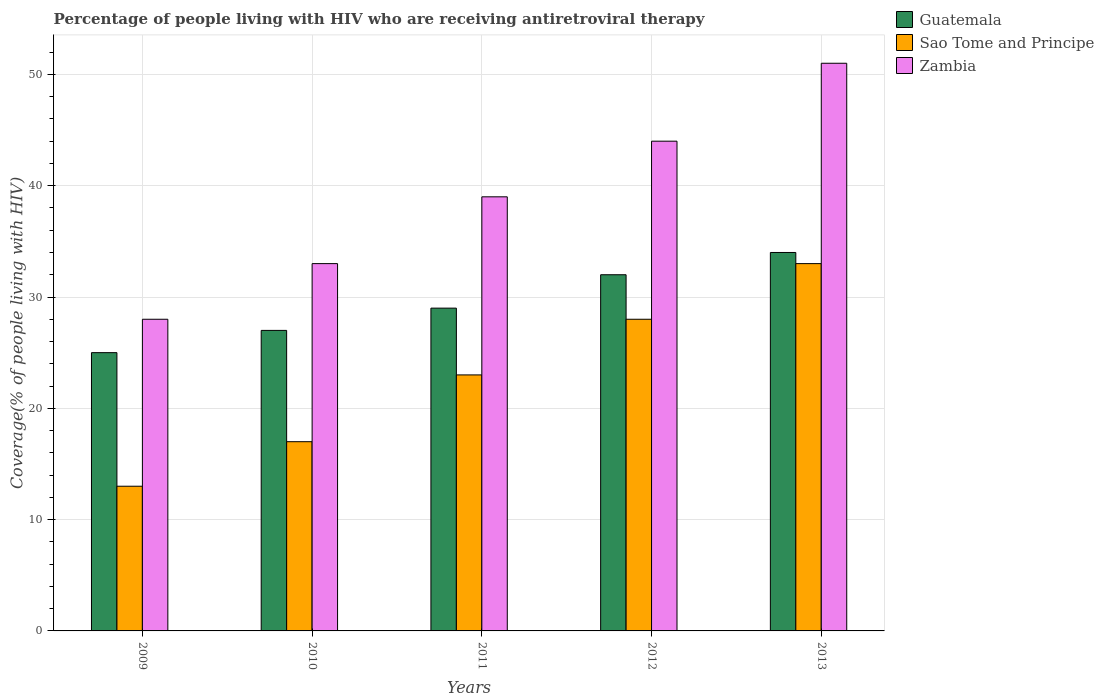Are the number of bars per tick equal to the number of legend labels?
Offer a very short reply. Yes. In how many cases, is the number of bars for a given year not equal to the number of legend labels?
Your answer should be compact. 0. What is the percentage of the HIV infected people who are receiving antiretroviral therapy in Zambia in 2010?
Provide a succinct answer. 33. Across all years, what is the maximum percentage of the HIV infected people who are receiving antiretroviral therapy in Zambia?
Your answer should be very brief. 51. Across all years, what is the minimum percentage of the HIV infected people who are receiving antiretroviral therapy in Zambia?
Give a very brief answer. 28. In which year was the percentage of the HIV infected people who are receiving antiretroviral therapy in Guatemala maximum?
Offer a very short reply. 2013. In which year was the percentage of the HIV infected people who are receiving antiretroviral therapy in Sao Tome and Principe minimum?
Offer a very short reply. 2009. What is the total percentage of the HIV infected people who are receiving antiretroviral therapy in Zambia in the graph?
Offer a very short reply. 195. What is the difference between the percentage of the HIV infected people who are receiving antiretroviral therapy in Zambia in 2009 and that in 2012?
Your answer should be compact. -16. What is the difference between the percentage of the HIV infected people who are receiving antiretroviral therapy in Guatemala in 2011 and the percentage of the HIV infected people who are receiving antiretroviral therapy in Zambia in 2012?
Offer a terse response. -15. What is the average percentage of the HIV infected people who are receiving antiretroviral therapy in Sao Tome and Principe per year?
Offer a very short reply. 22.8. In the year 2013, what is the difference between the percentage of the HIV infected people who are receiving antiretroviral therapy in Sao Tome and Principe and percentage of the HIV infected people who are receiving antiretroviral therapy in Guatemala?
Keep it short and to the point. -1. In how many years, is the percentage of the HIV infected people who are receiving antiretroviral therapy in Sao Tome and Principe greater than 34 %?
Keep it short and to the point. 0. What is the ratio of the percentage of the HIV infected people who are receiving antiretroviral therapy in Guatemala in 2010 to that in 2011?
Your answer should be very brief. 0.93. Is the percentage of the HIV infected people who are receiving antiretroviral therapy in Zambia in 2012 less than that in 2013?
Your response must be concise. Yes. What is the difference between the highest and the second highest percentage of the HIV infected people who are receiving antiretroviral therapy in Sao Tome and Principe?
Your response must be concise. 5. What is the difference between the highest and the lowest percentage of the HIV infected people who are receiving antiretroviral therapy in Sao Tome and Principe?
Ensure brevity in your answer.  20. In how many years, is the percentage of the HIV infected people who are receiving antiretroviral therapy in Guatemala greater than the average percentage of the HIV infected people who are receiving antiretroviral therapy in Guatemala taken over all years?
Offer a very short reply. 2. What does the 3rd bar from the left in 2012 represents?
Make the answer very short. Zambia. What does the 2nd bar from the right in 2011 represents?
Offer a terse response. Sao Tome and Principe. Are all the bars in the graph horizontal?
Provide a short and direct response. No. How many years are there in the graph?
Provide a succinct answer. 5. Does the graph contain any zero values?
Provide a short and direct response. No. How are the legend labels stacked?
Your response must be concise. Vertical. What is the title of the graph?
Give a very brief answer. Percentage of people living with HIV who are receiving antiretroviral therapy. Does "Central Europe" appear as one of the legend labels in the graph?
Your response must be concise. No. What is the label or title of the X-axis?
Provide a succinct answer. Years. What is the label or title of the Y-axis?
Offer a terse response. Coverage(% of people living with HIV). What is the Coverage(% of people living with HIV) of Guatemala in 2009?
Offer a terse response. 25. What is the Coverage(% of people living with HIV) in Guatemala in 2010?
Provide a short and direct response. 27. What is the Coverage(% of people living with HIV) of Sao Tome and Principe in 2010?
Your response must be concise. 17. What is the Coverage(% of people living with HIV) in Zambia in 2010?
Your answer should be compact. 33. What is the Coverage(% of people living with HIV) of Sao Tome and Principe in 2011?
Ensure brevity in your answer.  23. What is the Coverage(% of people living with HIV) in Zambia in 2011?
Your answer should be compact. 39. What is the Coverage(% of people living with HIV) of Guatemala in 2012?
Your answer should be very brief. 32. Across all years, what is the minimum Coverage(% of people living with HIV) of Zambia?
Provide a succinct answer. 28. What is the total Coverage(% of people living with HIV) of Guatemala in the graph?
Offer a very short reply. 147. What is the total Coverage(% of people living with HIV) in Sao Tome and Principe in the graph?
Provide a short and direct response. 114. What is the total Coverage(% of people living with HIV) of Zambia in the graph?
Make the answer very short. 195. What is the difference between the Coverage(% of people living with HIV) of Guatemala in 2009 and that in 2010?
Offer a terse response. -2. What is the difference between the Coverage(% of people living with HIV) of Sao Tome and Principe in 2009 and that in 2010?
Offer a terse response. -4. What is the difference between the Coverage(% of people living with HIV) in Zambia in 2009 and that in 2011?
Give a very brief answer. -11. What is the difference between the Coverage(% of people living with HIV) in Guatemala in 2009 and that in 2012?
Offer a terse response. -7. What is the difference between the Coverage(% of people living with HIV) of Guatemala in 2009 and that in 2013?
Provide a short and direct response. -9. What is the difference between the Coverage(% of people living with HIV) of Sao Tome and Principe in 2010 and that in 2011?
Make the answer very short. -6. What is the difference between the Coverage(% of people living with HIV) in Zambia in 2010 and that in 2011?
Give a very brief answer. -6. What is the difference between the Coverage(% of people living with HIV) of Guatemala in 2010 and that in 2012?
Your response must be concise. -5. What is the difference between the Coverage(% of people living with HIV) of Sao Tome and Principe in 2010 and that in 2012?
Keep it short and to the point. -11. What is the difference between the Coverage(% of people living with HIV) of Zambia in 2010 and that in 2012?
Make the answer very short. -11. What is the difference between the Coverage(% of people living with HIV) of Sao Tome and Principe in 2010 and that in 2013?
Keep it short and to the point. -16. What is the difference between the Coverage(% of people living with HIV) in Zambia in 2010 and that in 2013?
Keep it short and to the point. -18. What is the difference between the Coverage(% of people living with HIV) of Sao Tome and Principe in 2011 and that in 2012?
Ensure brevity in your answer.  -5. What is the difference between the Coverage(% of people living with HIV) in Zambia in 2011 and that in 2012?
Your answer should be compact. -5. What is the difference between the Coverage(% of people living with HIV) in Zambia in 2011 and that in 2013?
Keep it short and to the point. -12. What is the difference between the Coverage(% of people living with HIV) of Sao Tome and Principe in 2012 and that in 2013?
Offer a very short reply. -5. What is the difference between the Coverage(% of people living with HIV) in Zambia in 2012 and that in 2013?
Offer a terse response. -7. What is the difference between the Coverage(% of people living with HIV) of Guatemala in 2009 and the Coverage(% of people living with HIV) of Sao Tome and Principe in 2012?
Your answer should be very brief. -3. What is the difference between the Coverage(% of people living with HIV) in Guatemala in 2009 and the Coverage(% of people living with HIV) in Zambia in 2012?
Your answer should be compact. -19. What is the difference between the Coverage(% of people living with HIV) in Sao Tome and Principe in 2009 and the Coverage(% of people living with HIV) in Zambia in 2012?
Your answer should be compact. -31. What is the difference between the Coverage(% of people living with HIV) of Guatemala in 2009 and the Coverage(% of people living with HIV) of Zambia in 2013?
Your answer should be compact. -26. What is the difference between the Coverage(% of people living with HIV) in Sao Tome and Principe in 2009 and the Coverage(% of people living with HIV) in Zambia in 2013?
Keep it short and to the point. -38. What is the difference between the Coverage(% of people living with HIV) of Guatemala in 2010 and the Coverage(% of people living with HIV) of Sao Tome and Principe in 2011?
Provide a short and direct response. 4. What is the difference between the Coverage(% of people living with HIV) of Guatemala in 2010 and the Coverage(% of people living with HIV) of Zambia in 2011?
Provide a short and direct response. -12. What is the difference between the Coverage(% of people living with HIV) in Guatemala in 2010 and the Coverage(% of people living with HIV) in Sao Tome and Principe in 2013?
Offer a very short reply. -6. What is the difference between the Coverage(% of people living with HIV) in Sao Tome and Principe in 2010 and the Coverage(% of people living with HIV) in Zambia in 2013?
Your response must be concise. -34. What is the difference between the Coverage(% of people living with HIV) in Guatemala in 2011 and the Coverage(% of people living with HIV) in Sao Tome and Principe in 2012?
Provide a succinct answer. 1. What is the difference between the Coverage(% of people living with HIV) of Sao Tome and Principe in 2011 and the Coverage(% of people living with HIV) of Zambia in 2012?
Give a very brief answer. -21. What is the difference between the Coverage(% of people living with HIV) of Sao Tome and Principe in 2011 and the Coverage(% of people living with HIV) of Zambia in 2013?
Offer a very short reply. -28. What is the difference between the Coverage(% of people living with HIV) of Guatemala in 2012 and the Coverage(% of people living with HIV) of Sao Tome and Principe in 2013?
Offer a very short reply. -1. What is the difference between the Coverage(% of people living with HIV) of Guatemala in 2012 and the Coverage(% of people living with HIV) of Zambia in 2013?
Ensure brevity in your answer.  -19. What is the average Coverage(% of people living with HIV) of Guatemala per year?
Make the answer very short. 29.4. What is the average Coverage(% of people living with HIV) in Sao Tome and Principe per year?
Your answer should be compact. 22.8. What is the average Coverage(% of people living with HIV) of Zambia per year?
Your answer should be compact. 39. In the year 2009, what is the difference between the Coverage(% of people living with HIV) of Guatemala and Coverage(% of people living with HIV) of Zambia?
Offer a very short reply. -3. In the year 2009, what is the difference between the Coverage(% of people living with HIV) in Sao Tome and Principe and Coverage(% of people living with HIV) in Zambia?
Your answer should be compact. -15. In the year 2011, what is the difference between the Coverage(% of people living with HIV) in Sao Tome and Principe and Coverage(% of people living with HIV) in Zambia?
Make the answer very short. -16. In the year 2012, what is the difference between the Coverage(% of people living with HIV) in Guatemala and Coverage(% of people living with HIV) in Sao Tome and Principe?
Offer a very short reply. 4. In the year 2012, what is the difference between the Coverage(% of people living with HIV) in Guatemala and Coverage(% of people living with HIV) in Zambia?
Offer a terse response. -12. In the year 2013, what is the difference between the Coverage(% of people living with HIV) in Guatemala and Coverage(% of people living with HIV) in Sao Tome and Principe?
Keep it short and to the point. 1. What is the ratio of the Coverage(% of people living with HIV) of Guatemala in 2009 to that in 2010?
Give a very brief answer. 0.93. What is the ratio of the Coverage(% of people living with HIV) in Sao Tome and Principe in 2009 to that in 2010?
Ensure brevity in your answer.  0.76. What is the ratio of the Coverage(% of people living with HIV) of Zambia in 2009 to that in 2010?
Make the answer very short. 0.85. What is the ratio of the Coverage(% of people living with HIV) of Guatemala in 2009 to that in 2011?
Provide a short and direct response. 0.86. What is the ratio of the Coverage(% of people living with HIV) in Sao Tome and Principe in 2009 to that in 2011?
Provide a succinct answer. 0.57. What is the ratio of the Coverage(% of people living with HIV) in Zambia in 2009 to that in 2011?
Offer a very short reply. 0.72. What is the ratio of the Coverage(% of people living with HIV) of Guatemala in 2009 to that in 2012?
Your answer should be very brief. 0.78. What is the ratio of the Coverage(% of people living with HIV) in Sao Tome and Principe in 2009 to that in 2012?
Offer a very short reply. 0.46. What is the ratio of the Coverage(% of people living with HIV) of Zambia in 2009 to that in 2012?
Offer a terse response. 0.64. What is the ratio of the Coverage(% of people living with HIV) of Guatemala in 2009 to that in 2013?
Your response must be concise. 0.74. What is the ratio of the Coverage(% of people living with HIV) of Sao Tome and Principe in 2009 to that in 2013?
Provide a succinct answer. 0.39. What is the ratio of the Coverage(% of people living with HIV) in Zambia in 2009 to that in 2013?
Your response must be concise. 0.55. What is the ratio of the Coverage(% of people living with HIV) in Guatemala in 2010 to that in 2011?
Your response must be concise. 0.93. What is the ratio of the Coverage(% of people living with HIV) in Sao Tome and Principe in 2010 to that in 2011?
Your response must be concise. 0.74. What is the ratio of the Coverage(% of people living with HIV) in Zambia in 2010 to that in 2011?
Your answer should be compact. 0.85. What is the ratio of the Coverage(% of people living with HIV) of Guatemala in 2010 to that in 2012?
Your answer should be compact. 0.84. What is the ratio of the Coverage(% of people living with HIV) of Sao Tome and Principe in 2010 to that in 2012?
Your answer should be compact. 0.61. What is the ratio of the Coverage(% of people living with HIV) in Zambia in 2010 to that in 2012?
Give a very brief answer. 0.75. What is the ratio of the Coverage(% of people living with HIV) of Guatemala in 2010 to that in 2013?
Offer a very short reply. 0.79. What is the ratio of the Coverage(% of people living with HIV) of Sao Tome and Principe in 2010 to that in 2013?
Give a very brief answer. 0.52. What is the ratio of the Coverage(% of people living with HIV) in Zambia in 2010 to that in 2013?
Provide a short and direct response. 0.65. What is the ratio of the Coverage(% of people living with HIV) of Guatemala in 2011 to that in 2012?
Your response must be concise. 0.91. What is the ratio of the Coverage(% of people living with HIV) of Sao Tome and Principe in 2011 to that in 2012?
Provide a succinct answer. 0.82. What is the ratio of the Coverage(% of people living with HIV) of Zambia in 2011 to that in 2012?
Ensure brevity in your answer.  0.89. What is the ratio of the Coverage(% of people living with HIV) of Guatemala in 2011 to that in 2013?
Ensure brevity in your answer.  0.85. What is the ratio of the Coverage(% of people living with HIV) in Sao Tome and Principe in 2011 to that in 2013?
Your answer should be very brief. 0.7. What is the ratio of the Coverage(% of people living with HIV) of Zambia in 2011 to that in 2013?
Provide a succinct answer. 0.76. What is the ratio of the Coverage(% of people living with HIV) of Guatemala in 2012 to that in 2013?
Your response must be concise. 0.94. What is the ratio of the Coverage(% of people living with HIV) of Sao Tome and Principe in 2012 to that in 2013?
Provide a short and direct response. 0.85. What is the ratio of the Coverage(% of people living with HIV) of Zambia in 2012 to that in 2013?
Your answer should be compact. 0.86. What is the difference between the highest and the second highest Coverage(% of people living with HIV) in Guatemala?
Your answer should be compact. 2. What is the difference between the highest and the lowest Coverage(% of people living with HIV) of Sao Tome and Principe?
Make the answer very short. 20. 